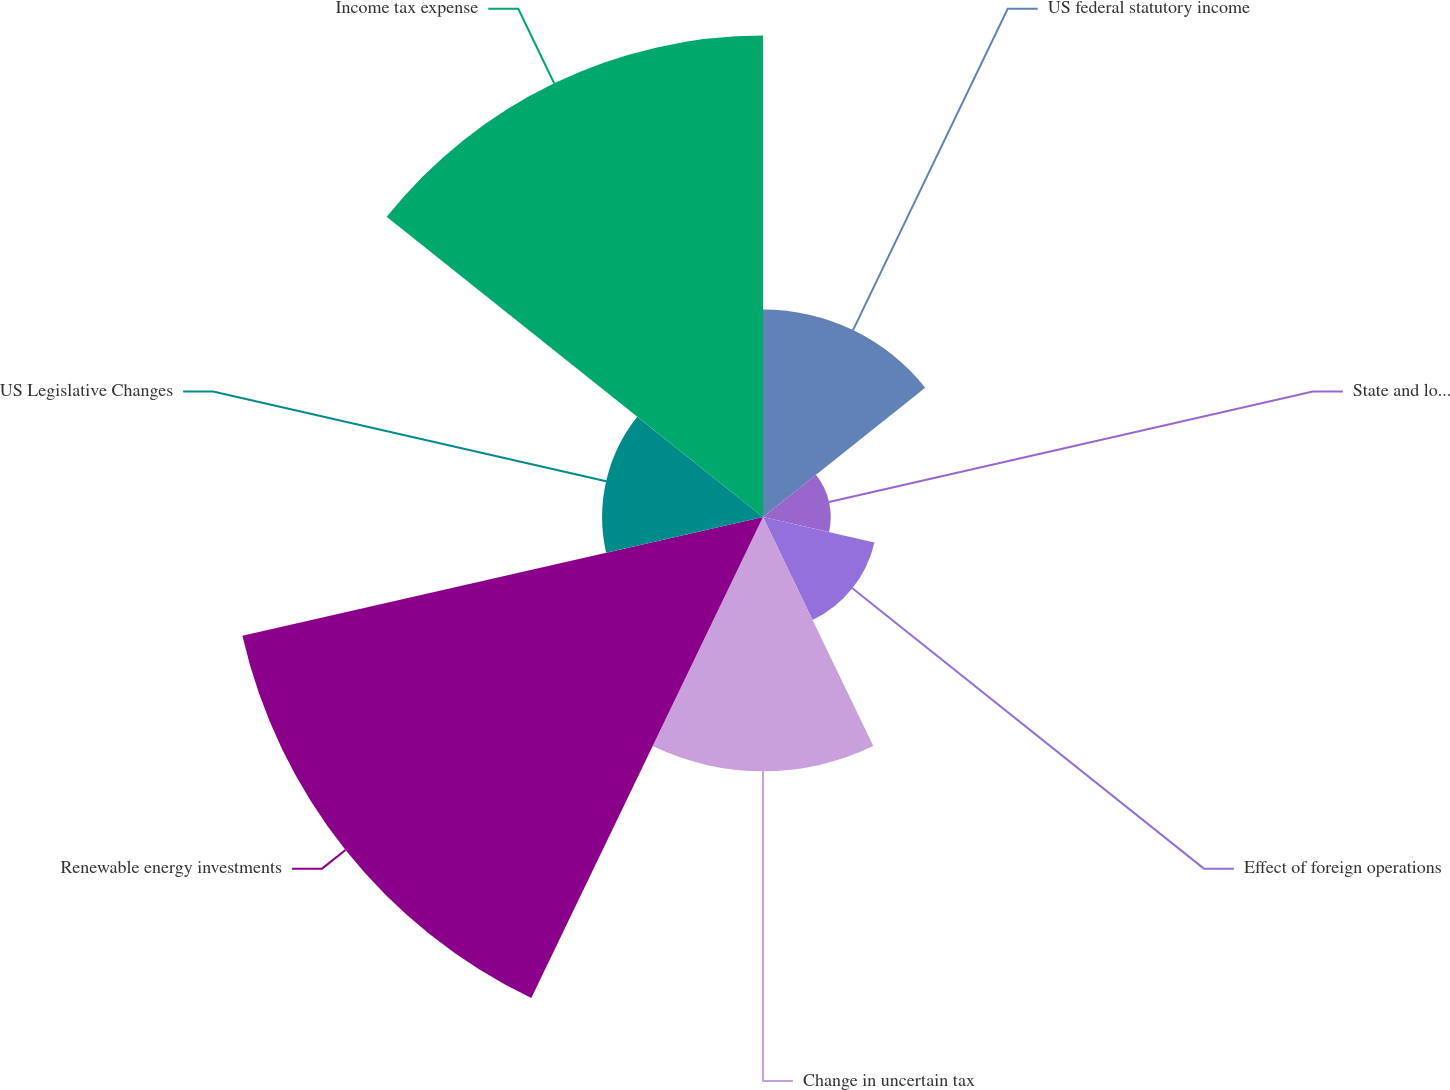<chart> <loc_0><loc_0><loc_500><loc_500><pie_chart><fcel>US federal statutory income<fcel>State and local income taxes<fcel>Effect of foreign operations<fcel>Change in uncertain tax<fcel>Renewable energy investments<fcel>US Legislative Changes<fcel>Income tax expense<nl><fcel>11.4%<fcel>3.72%<fcel>6.28%<fcel>13.97%<fcel>29.34%<fcel>8.84%<fcel>26.45%<nl></chart> 